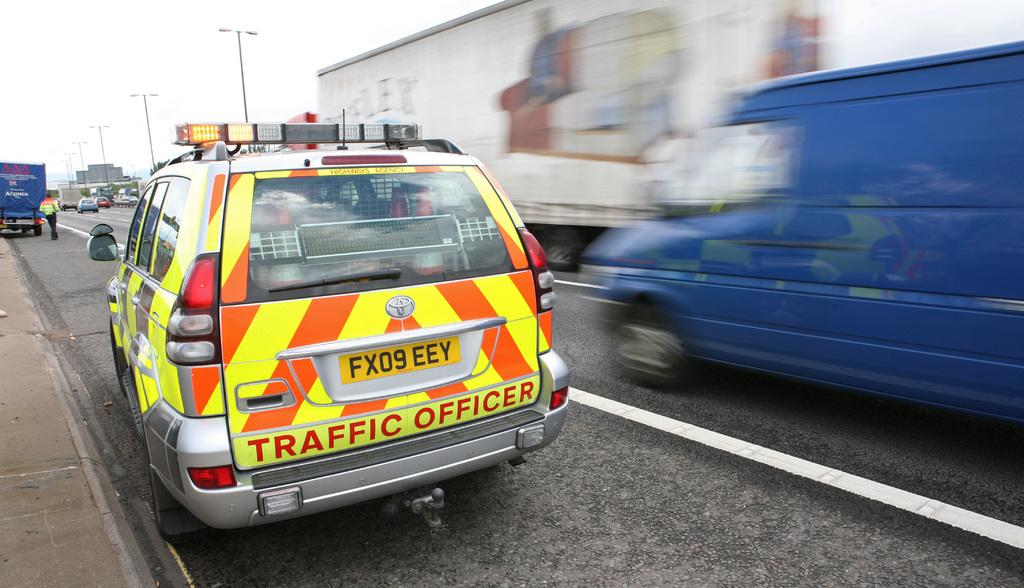What is the tag number?
Provide a succinct answer. Fx09 eey. What kind of vehicle is this?
Your response must be concise. Traffic officer. 